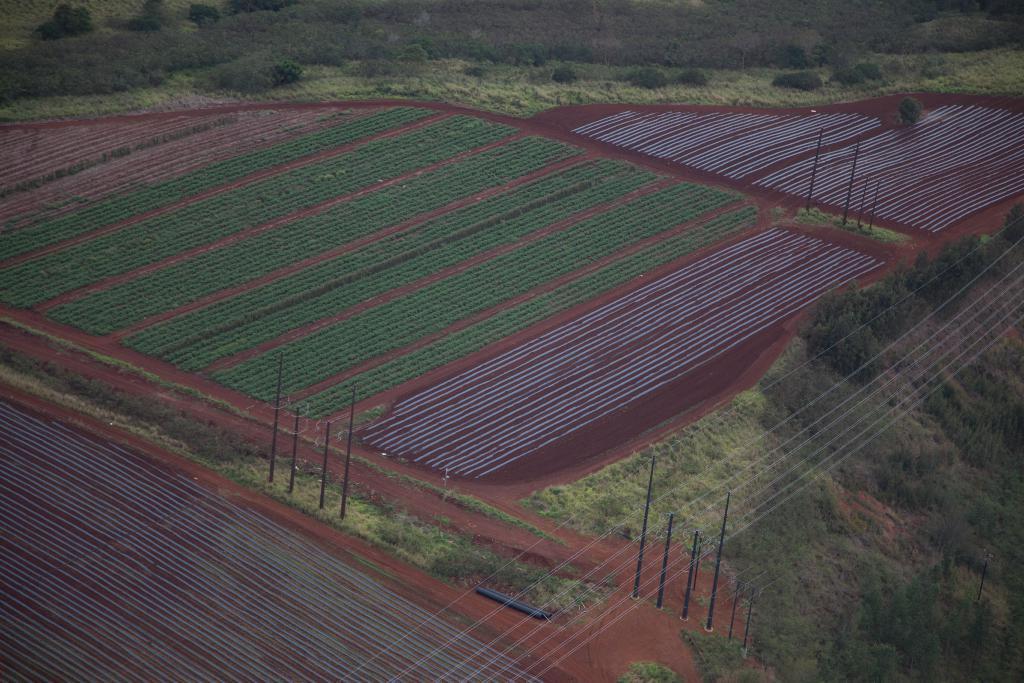Please provide a concise description of this image. In this image, we can see fields and in the background, there are trees, poles and wires. 